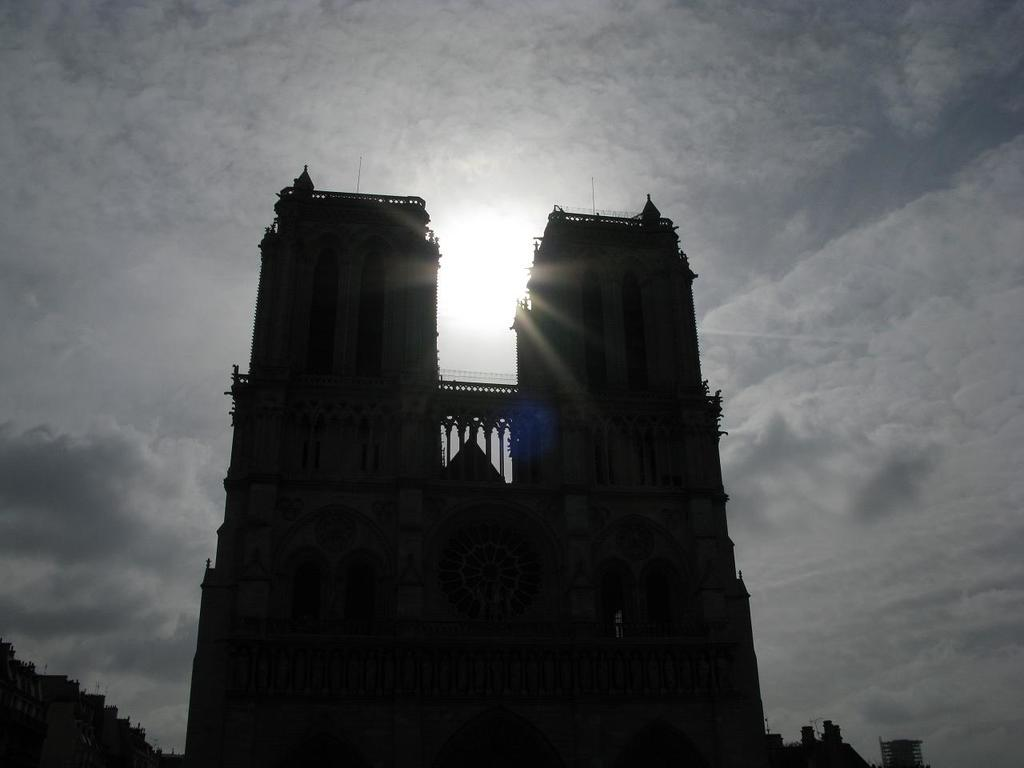What structures are present in the image? There are buildings in the image. What can be seen in the background of the image? The sky is visible in the background of the image. How does the coach heal the wound in the image? There is no coach or wound present in the image; it only features buildings and the sky. 